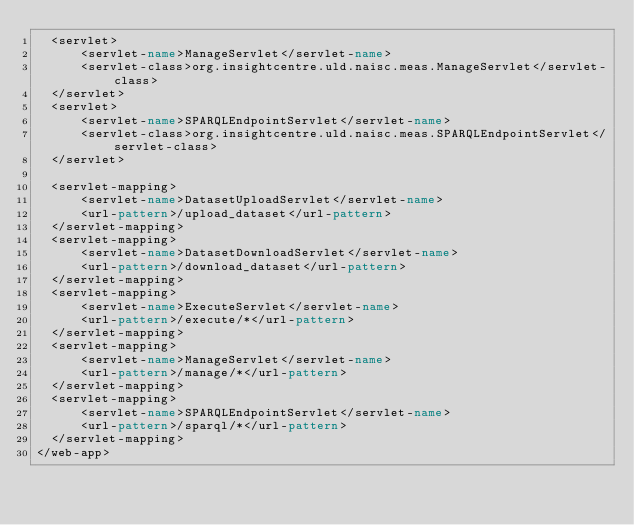Convert code to text. <code><loc_0><loc_0><loc_500><loc_500><_XML_>  <servlet>
      <servlet-name>ManageServlet</servlet-name>
      <servlet-class>org.insightcentre.uld.naisc.meas.ManageServlet</servlet-class>
  </servlet>
  <servlet>
      <servlet-name>SPARQLEndpointServlet</servlet-name>
      <servlet-class>org.insightcentre.uld.naisc.meas.SPARQLEndpointServlet</servlet-class>
  </servlet>
  
  <servlet-mapping>
      <servlet-name>DatasetUploadServlet</servlet-name>
      <url-pattern>/upload_dataset</url-pattern>
  </servlet-mapping>
  <servlet-mapping>
      <servlet-name>DatasetDownloadServlet</servlet-name>
      <url-pattern>/download_dataset</url-pattern>
  </servlet-mapping>
  <servlet-mapping>
      <servlet-name>ExecuteServlet</servlet-name>
      <url-pattern>/execute/*</url-pattern>
  </servlet-mapping>
  <servlet-mapping>
      <servlet-name>ManageServlet</servlet-name>
      <url-pattern>/manage/*</url-pattern>
  </servlet-mapping>
  <servlet-mapping>
      <servlet-name>SPARQLEndpointServlet</servlet-name>
      <url-pattern>/sparql/*</url-pattern>
  </servlet-mapping>
</web-app>
</code> 